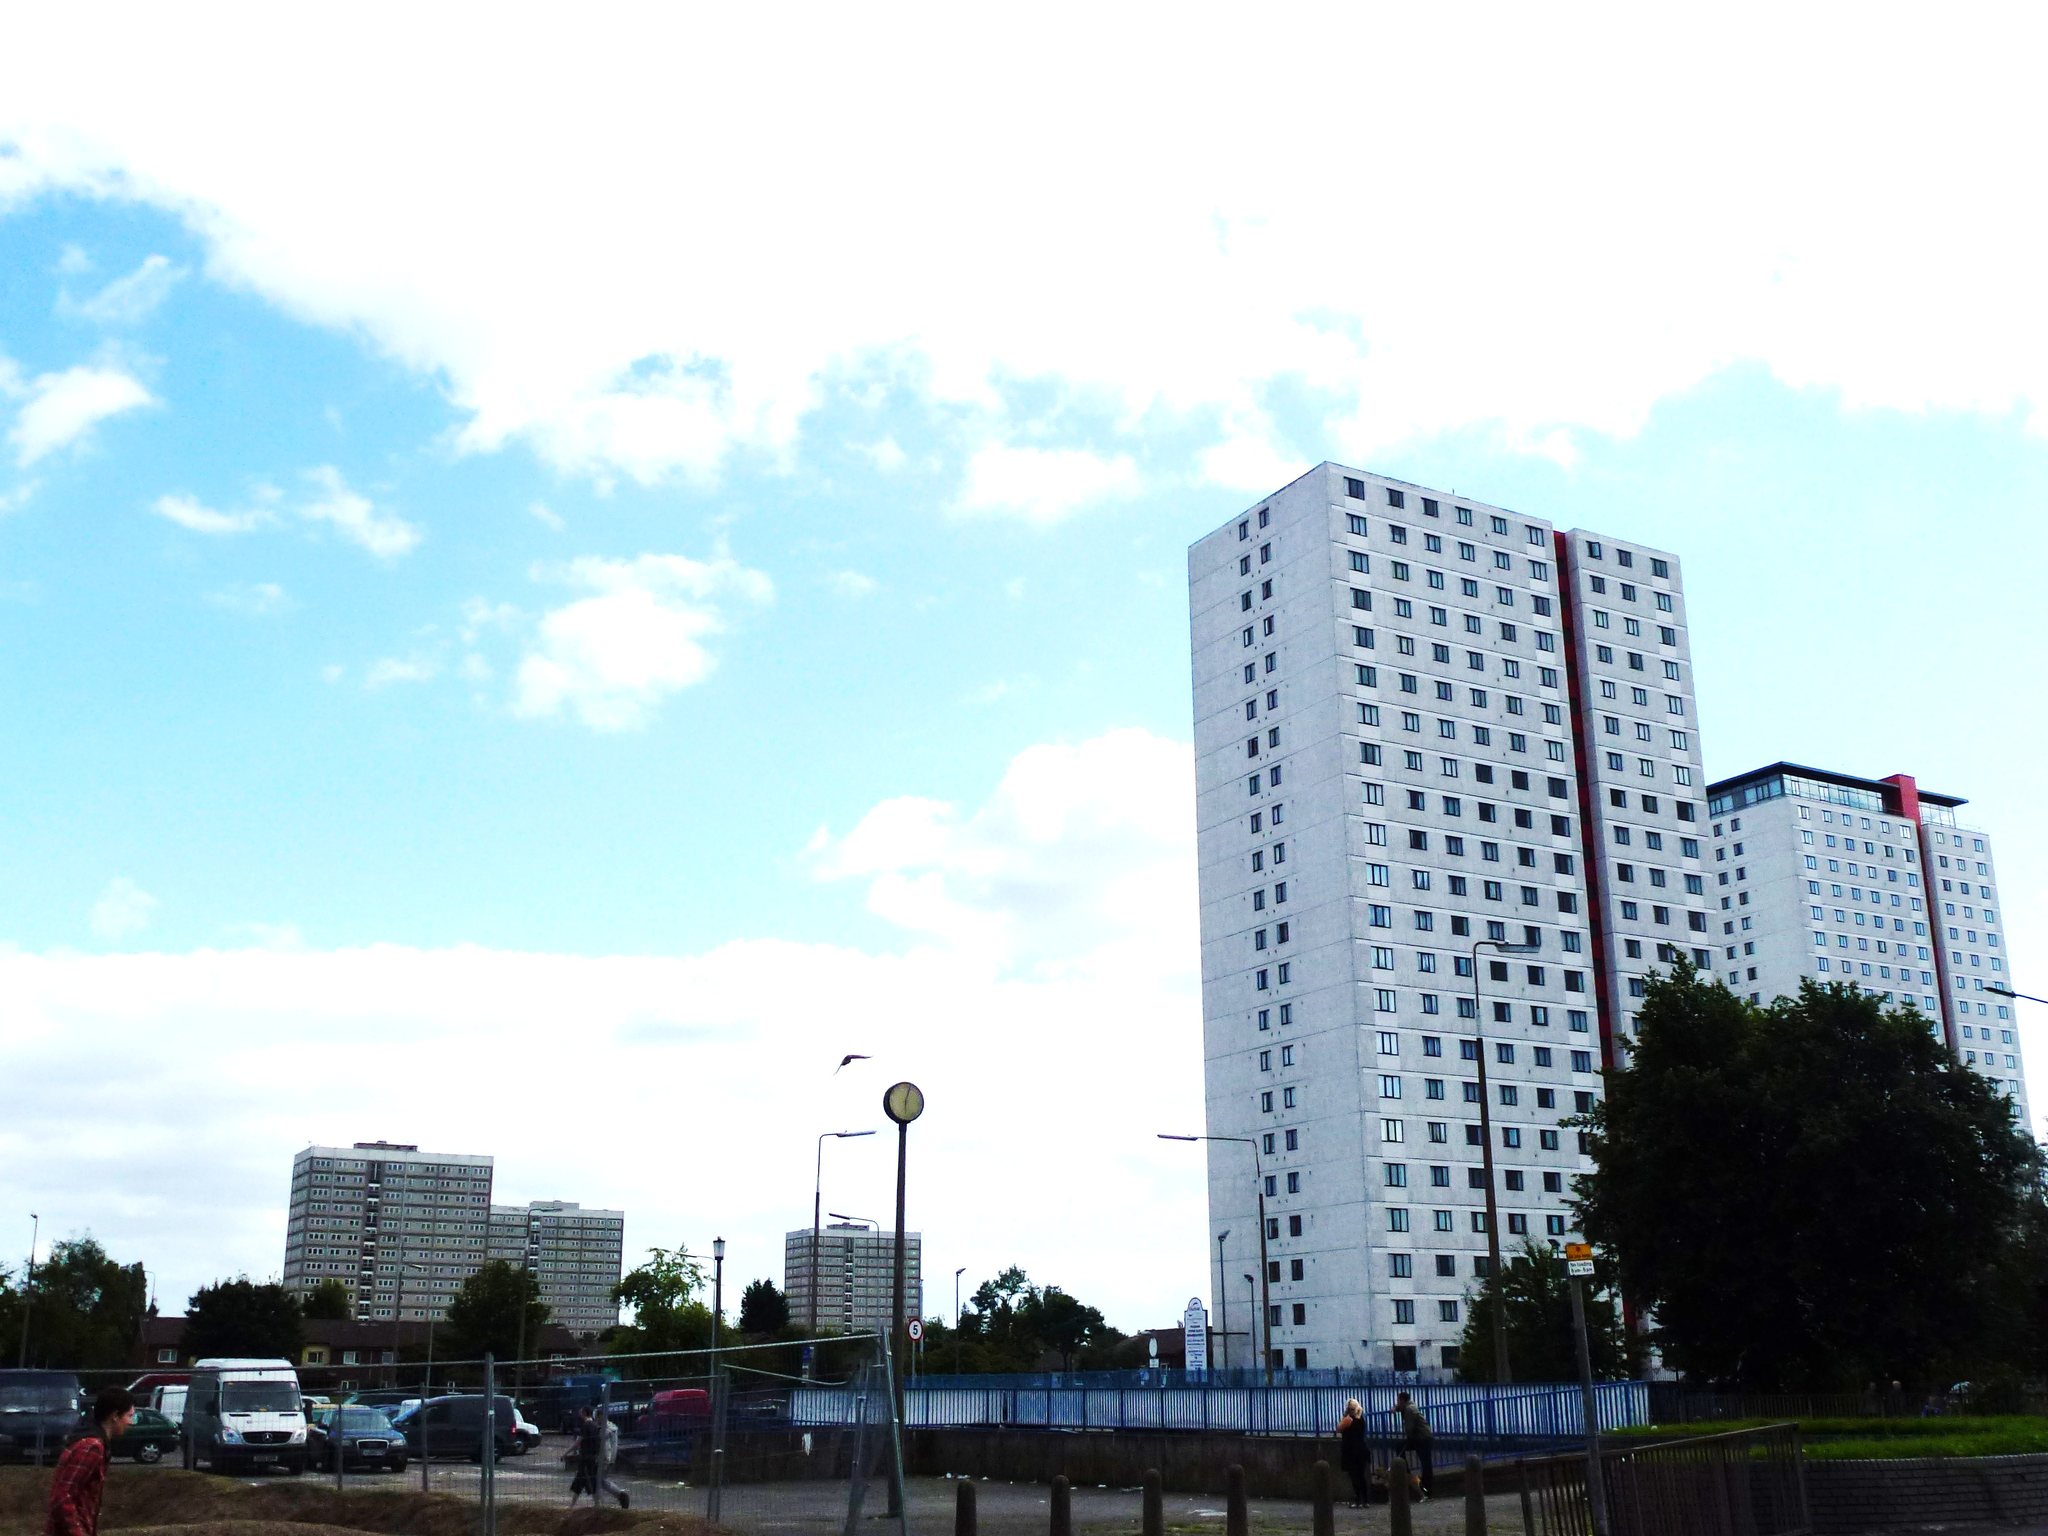Could you give a brief overview of what you see in this image? In this picture we can see vehicles on the road, some people, fences, buildings, trees, light poles and some objects and in the background we can see the sky with clouds. 